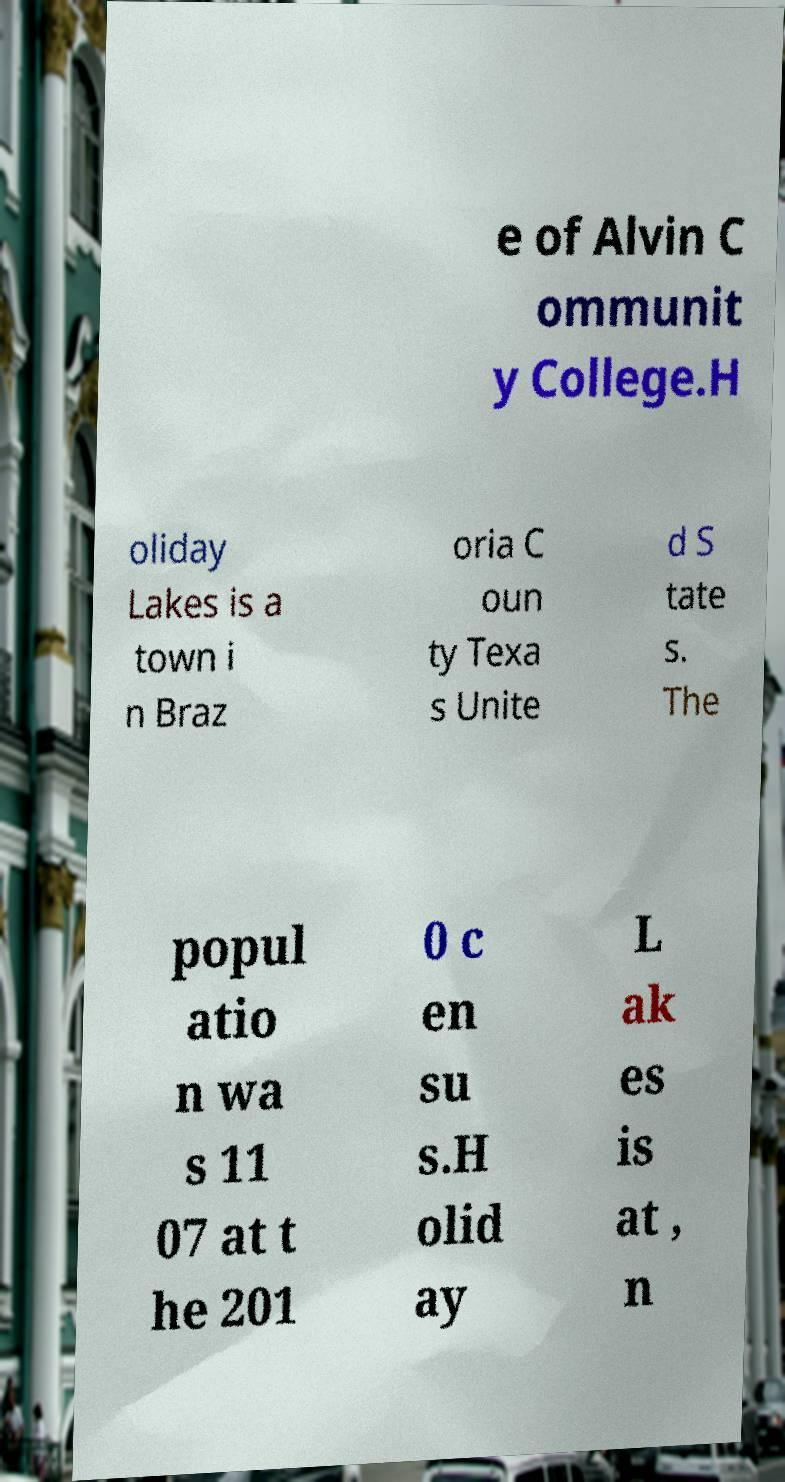Can you read and provide the text displayed in the image?This photo seems to have some interesting text. Can you extract and type it out for me? e of Alvin C ommunit y College.H oliday Lakes is a town i n Braz oria C oun ty Texa s Unite d S tate s. The popul atio n wa s 11 07 at t he 201 0 c en su s.H olid ay L ak es is at , n 